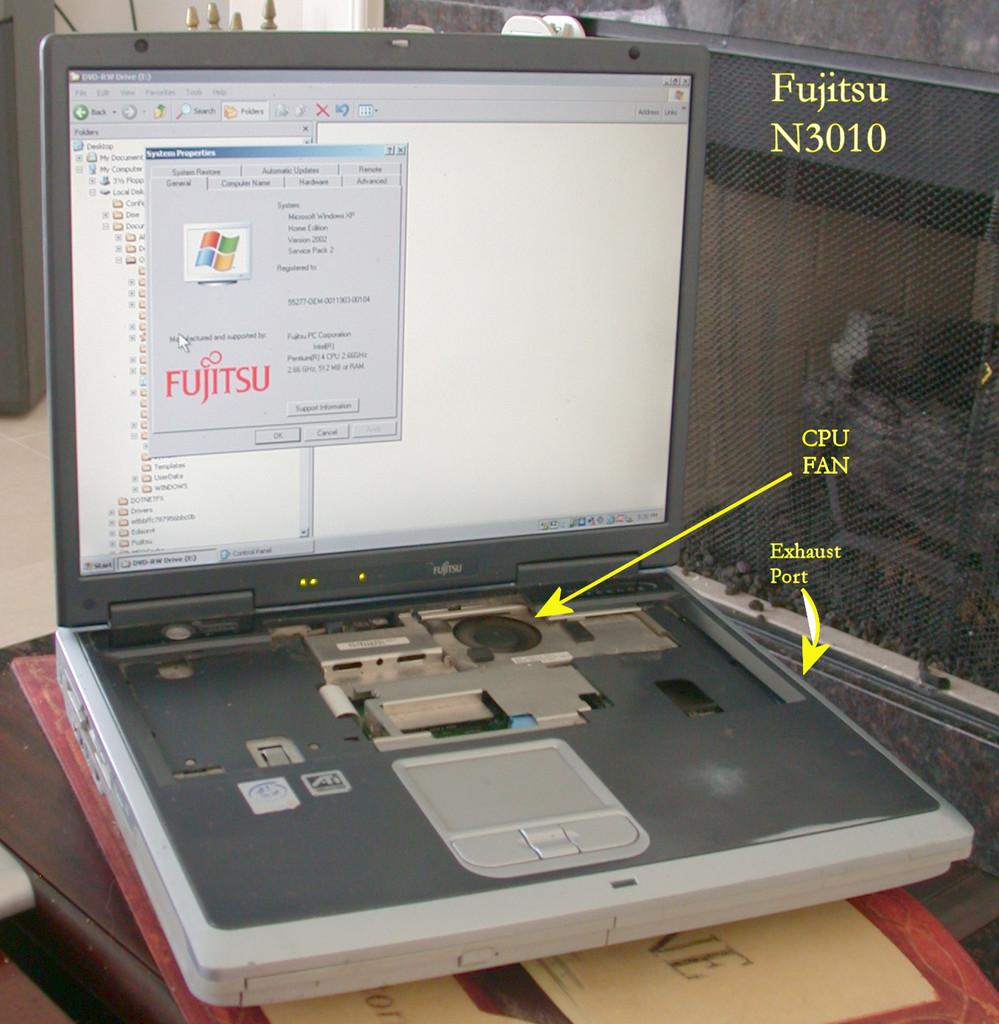<image>
Describe the image concisely. a laptop with the keyboard missing and parts cpu fan and exhaust port labeled in yellow 